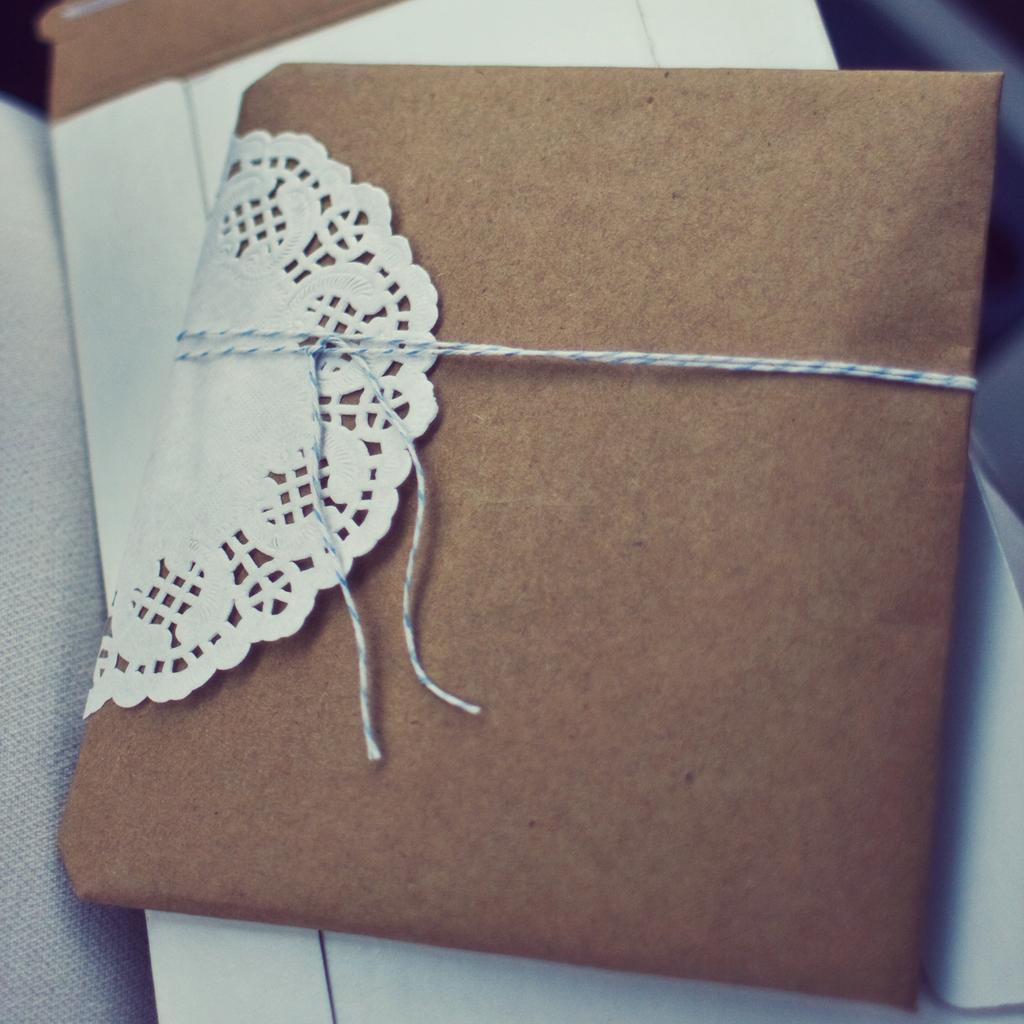How would you summarize this image in a sentence or two? In this image there is a wedding card on blanket. It is tied with a thread. 